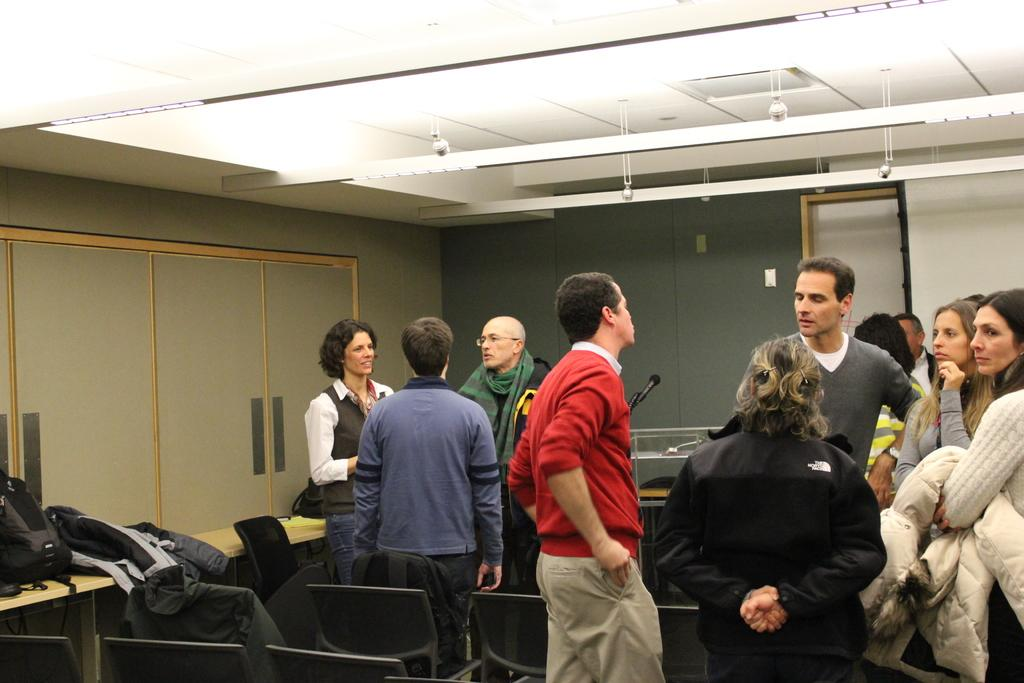What type of bag is visible in the image? There is a backpack in the image. What type of clothing can be seen in the image? There are jackets in the image. What type of furniture is present in the image? There are chairs and a table in the image. What type of structure is present in the image? There is a podium in the image. What type of lighting is present in the image? There are lights in the image. What type of architectural feature is present in the image? There is a ceiling in the image. What type of communication device is present in the image? There is a microphone in the image. What type of objects are present in the image? There are objects in the image. What type of people are present in the image? There are people standing in the image. What is the average income of the people standing in the image? There is no information about the income of the people in the image. How much respect is shown by the people standing in the image? There is no information about the level of respect shown by the people in the image. 